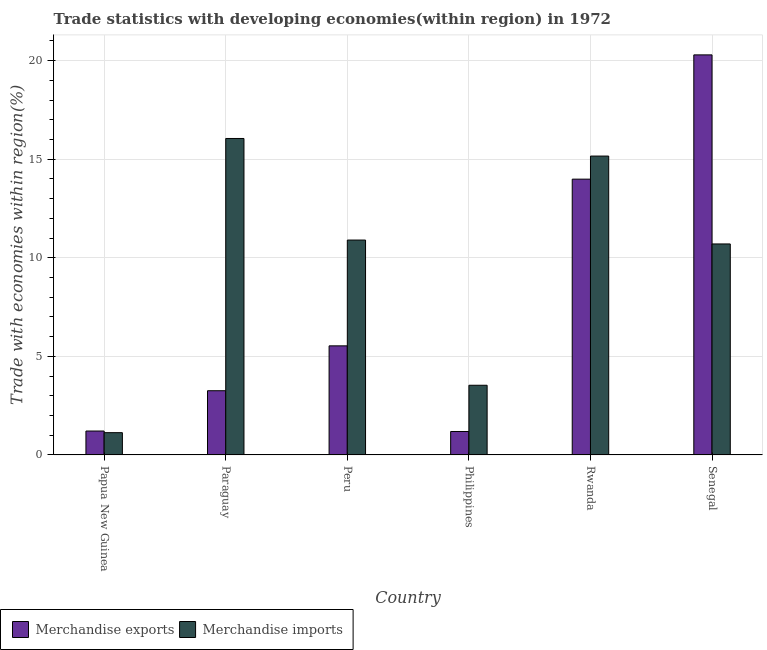How many groups of bars are there?
Provide a succinct answer. 6. Are the number of bars per tick equal to the number of legend labels?
Your answer should be very brief. Yes. Are the number of bars on each tick of the X-axis equal?
Provide a short and direct response. Yes. How many bars are there on the 2nd tick from the left?
Ensure brevity in your answer.  2. How many bars are there on the 5th tick from the right?
Ensure brevity in your answer.  2. What is the label of the 6th group of bars from the left?
Make the answer very short. Senegal. What is the merchandise exports in Philippines?
Your answer should be very brief. 1.19. Across all countries, what is the maximum merchandise imports?
Offer a very short reply. 16.05. Across all countries, what is the minimum merchandise exports?
Your answer should be very brief. 1.19. In which country was the merchandise exports maximum?
Give a very brief answer. Senegal. In which country was the merchandise imports minimum?
Offer a very short reply. Papua New Guinea. What is the total merchandise exports in the graph?
Keep it short and to the point. 45.48. What is the difference between the merchandise exports in Philippines and that in Rwanda?
Provide a short and direct response. -12.8. What is the difference between the merchandise imports in Paraguay and the merchandise exports in Rwanda?
Give a very brief answer. 2.06. What is the average merchandise exports per country?
Keep it short and to the point. 7.58. What is the difference between the merchandise imports and merchandise exports in Senegal?
Provide a succinct answer. -9.59. In how many countries, is the merchandise exports greater than 18 %?
Offer a very short reply. 1. What is the ratio of the merchandise exports in Paraguay to that in Senegal?
Provide a succinct answer. 0.16. What is the difference between the highest and the second highest merchandise imports?
Offer a terse response. 0.89. What is the difference between the highest and the lowest merchandise exports?
Keep it short and to the point. 19.1. What does the 2nd bar from the left in Peru represents?
Make the answer very short. Merchandise imports. How many bars are there?
Keep it short and to the point. 12. How many countries are there in the graph?
Your answer should be compact. 6. What is the difference between two consecutive major ticks on the Y-axis?
Your answer should be very brief. 5. Are the values on the major ticks of Y-axis written in scientific E-notation?
Keep it short and to the point. No. Does the graph contain grids?
Provide a short and direct response. Yes. Where does the legend appear in the graph?
Keep it short and to the point. Bottom left. What is the title of the graph?
Provide a succinct answer. Trade statistics with developing economies(within region) in 1972. Does "Long-term debt" appear as one of the legend labels in the graph?
Offer a terse response. No. What is the label or title of the Y-axis?
Offer a terse response. Trade with economies within region(%). What is the Trade with economies within region(%) of Merchandise exports in Papua New Guinea?
Your answer should be very brief. 1.21. What is the Trade with economies within region(%) in Merchandise imports in Papua New Guinea?
Your answer should be very brief. 1.13. What is the Trade with economies within region(%) in Merchandise exports in Paraguay?
Offer a very short reply. 3.26. What is the Trade with economies within region(%) of Merchandise imports in Paraguay?
Keep it short and to the point. 16.05. What is the Trade with economies within region(%) in Merchandise exports in Peru?
Offer a terse response. 5.53. What is the Trade with economies within region(%) of Merchandise imports in Peru?
Offer a terse response. 10.9. What is the Trade with economies within region(%) of Merchandise exports in Philippines?
Ensure brevity in your answer.  1.19. What is the Trade with economies within region(%) in Merchandise imports in Philippines?
Provide a succinct answer. 3.53. What is the Trade with economies within region(%) of Merchandise exports in Rwanda?
Make the answer very short. 13.99. What is the Trade with economies within region(%) of Merchandise imports in Rwanda?
Give a very brief answer. 15.16. What is the Trade with economies within region(%) in Merchandise exports in Senegal?
Make the answer very short. 20.29. What is the Trade with economies within region(%) of Merchandise imports in Senegal?
Give a very brief answer. 10.7. Across all countries, what is the maximum Trade with economies within region(%) in Merchandise exports?
Provide a succinct answer. 20.29. Across all countries, what is the maximum Trade with economies within region(%) in Merchandise imports?
Give a very brief answer. 16.05. Across all countries, what is the minimum Trade with economies within region(%) in Merchandise exports?
Make the answer very short. 1.19. Across all countries, what is the minimum Trade with economies within region(%) of Merchandise imports?
Your answer should be very brief. 1.13. What is the total Trade with economies within region(%) in Merchandise exports in the graph?
Provide a short and direct response. 45.48. What is the total Trade with economies within region(%) in Merchandise imports in the graph?
Your answer should be compact. 57.48. What is the difference between the Trade with economies within region(%) in Merchandise exports in Papua New Guinea and that in Paraguay?
Offer a very short reply. -2.04. What is the difference between the Trade with economies within region(%) of Merchandise imports in Papua New Guinea and that in Paraguay?
Your response must be concise. -14.92. What is the difference between the Trade with economies within region(%) in Merchandise exports in Papua New Guinea and that in Peru?
Your response must be concise. -4.32. What is the difference between the Trade with economies within region(%) in Merchandise imports in Papua New Guinea and that in Peru?
Your answer should be compact. -9.77. What is the difference between the Trade with economies within region(%) of Merchandise exports in Papua New Guinea and that in Philippines?
Offer a very short reply. 0.02. What is the difference between the Trade with economies within region(%) of Merchandise imports in Papua New Guinea and that in Philippines?
Your answer should be compact. -2.41. What is the difference between the Trade with economies within region(%) of Merchandise exports in Papua New Guinea and that in Rwanda?
Give a very brief answer. -12.78. What is the difference between the Trade with economies within region(%) in Merchandise imports in Papua New Guinea and that in Rwanda?
Provide a short and direct response. -14.03. What is the difference between the Trade with economies within region(%) in Merchandise exports in Papua New Guinea and that in Senegal?
Keep it short and to the point. -19.08. What is the difference between the Trade with economies within region(%) of Merchandise imports in Papua New Guinea and that in Senegal?
Provide a short and direct response. -9.57. What is the difference between the Trade with economies within region(%) of Merchandise exports in Paraguay and that in Peru?
Provide a short and direct response. -2.28. What is the difference between the Trade with economies within region(%) in Merchandise imports in Paraguay and that in Peru?
Provide a succinct answer. 5.15. What is the difference between the Trade with economies within region(%) of Merchandise exports in Paraguay and that in Philippines?
Your answer should be compact. 2.07. What is the difference between the Trade with economies within region(%) of Merchandise imports in Paraguay and that in Philippines?
Offer a very short reply. 12.52. What is the difference between the Trade with economies within region(%) of Merchandise exports in Paraguay and that in Rwanda?
Make the answer very short. -10.73. What is the difference between the Trade with economies within region(%) of Merchandise imports in Paraguay and that in Rwanda?
Provide a short and direct response. 0.89. What is the difference between the Trade with economies within region(%) of Merchandise exports in Paraguay and that in Senegal?
Ensure brevity in your answer.  -17.04. What is the difference between the Trade with economies within region(%) in Merchandise imports in Paraguay and that in Senegal?
Your answer should be very brief. 5.35. What is the difference between the Trade with economies within region(%) in Merchandise exports in Peru and that in Philippines?
Offer a terse response. 4.34. What is the difference between the Trade with economies within region(%) of Merchandise imports in Peru and that in Philippines?
Your answer should be very brief. 7.37. What is the difference between the Trade with economies within region(%) of Merchandise exports in Peru and that in Rwanda?
Ensure brevity in your answer.  -8.46. What is the difference between the Trade with economies within region(%) of Merchandise imports in Peru and that in Rwanda?
Your answer should be compact. -4.26. What is the difference between the Trade with economies within region(%) of Merchandise exports in Peru and that in Senegal?
Give a very brief answer. -14.76. What is the difference between the Trade with economies within region(%) in Merchandise imports in Peru and that in Senegal?
Provide a succinct answer. 0.2. What is the difference between the Trade with economies within region(%) of Merchandise exports in Philippines and that in Rwanda?
Give a very brief answer. -12.8. What is the difference between the Trade with economies within region(%) of Merchandise imports in Philippines and that in Rwanda?
Provide a short and direct response. -11.63. What is the difference between the Trade with economies within region(%) in Merchandise exports in Philippines and that in Senegal?
Provide a succinct answer. -19.1. What is the difference between the Trade with economies within region(%) in Merchandise imports in Philippines and that in Senegal?
Give a very brief answer. -7.17. What is the difference between the Trade with economies within region(%) of Merchandise exports in Rwanda and that in Senegal?
Ensure brevity in your answer.  -6.3. What is the difference between the Trade with economies within region(%) of Merchandise imports in Rwanda and that in Senegal?
Provide a short and direct response. 4.46. What is the difference between the Trade with economies within region(%) in Merchandise exports in Papua New Guinea and the Trade with economies within region(%) in Merchandise imports in Paraguay?
Provide a short and direct response. -14.84. What is the difference between the Trade with economies within region(%) in Merchandise exports in Papua New Guinea and the Trade with economies within region(%) in Merchandise imports in Peru?
Give a very brief answer. -9.69. What is the difference between the Trade with economies within region(%) of Merchandise exports in Papua New Guinea and the Trade with economies within region(%) of Merchandise imports in Philippines?
Make the answer very short. -2.32. What is the difference between the Trade with economies within region(%) of Merchandise exports in Papua New Guinea and the Trade with economies within region(%) of Merchandise imports in Rwanda?
Provide a short and direct response. -13.95. What is the difference between the Trade with economies within region(%) of Merchandise exports in Papua New Guinea and the Trade with economies within region(%) of Merchandise imports in Senegal?
Your answer should be very brief. -9.49. What is the difference between the Trade with economies within region(%) of Merchandise exports in Paraguay and the Trade with economies within region(%) of Merchandise imports in Peru?
Keep it short and to the point. -7.64. What is the difference between the Trade with economies within region(%) of Merchandise exports in Paraguay and the Trade with economies within region(%) of Merchandise imports in Philippines?
Your response must be concise. -0.28. What is the difference between the Trade with economies within region(%) in Merchandise exports in Paraguay and the Trade with economies within region(%) in Merchandise imports in Rwanda?
Ensure brevity in your answer.  -11.9. What is the difference between the Trade with economies within region(%) of Merchandise exports in Paraguay and the Trade with economies within region(%) of Merchandise imports in Senegal?
Ensure brevity in your answer.  -7.45. What is the difference between the Trade with economies within region(%) of Merchandise exports in Peru and the Trade with economies within region(%) of Merchandise imports in Philippines?
Offer a terse response. 2. What is the difference between the Trade with economies within region(%) of Merchandise exports in Peru and the Trade with economies within region(%) of Merchandise imports in Rwanda?
Offer a terse response. -9.63. What is the difference between the Trade with economies within region(%) of Merchandise exports in Peru and the Trade with economies within region(%) of Merchandise imports in Senegal?
Offer a very short reply. -5.17. What is the difference between the Trade with economies within region(%) of Merchandise exports in Philippines and the Trade with economies within region(%) of Merchandise imports in Rwanda?
Make the answer very short. -13.97. What is the difference between the Trade with economies within region(%) in Merchandise exports in Philippines and the Trade with economies within region(%) in Merchandise imports in Senegal?
Provide a succinct answer. -9.51. What is the difference between the Trade with economies within region(%) in Merchandise exports in Rwanda and the Trade with economies within region(%) in Merchandise imports in Senegal?
Offer a very short reply. 3.29. What is the average Trade with economies within region(%) of Merchandise exports per country?
Your answer should be very brief. 7.58. What is the average Trade with economies within region(%) in Merchandise imports per country?
Offer a terse response. 9.58. What is the difference between the Trade with economies within region(%) in Merchandise exports and Trade with economies within region(%) in Merchandise imports in Papua New Guinea?
Provide a succinct answer. 0.08. What is the difference between the Trade with economies within region(%) in Merchandise exports and Trade with economies within region(%) in Merchandise imports in Paraguay?
Keep it short and to the point. -12.8. What is the difference between the Trade with economies within region(%) of Merchandise exports and Trade with economies within region(%) of Merchandise imports in Peru?
Give a very brief answer. -5.37. What is the difference between the Trade with economies within region(%) in Merchandise exports and Trade with economies within region(%) in Merchandise imports in Philippines?
Your response must be concise. -2.35. What is the difference between the Trade with economies within region(%) in Merchandise exports and Trade with economies within region(%) in Merchandise imports in Rwanda?
Provide a short and direct response. -1.17. What is the difference between the Trade with economies within region(%) in Merchandise exports and Trade with economies within region(%) in Merchandise imports in Senegal?
Ensure brevity in your answer.  9.59. What is the ratio of the Trade with economies within region(%) in Merchandise exports in Papua New Guinea to that in Paraguay?
Your response must be concise. 0.37. What is the ratio of the Trade with economies within region(%) in Merchandise imports in Papua New Guinea to that in Paraguay?
Your response must be concise. 0.07. What is the ratio of the Trade with economies within region(%) in Merchandise exports in Papua New Guinea to that in Peru?
Offer a very short reply. 0.22. What is the ratio of the Trade with economies within region(%) of Merchandise imports in Papua New Guinea to that in Peru?
Your answer should be compact. 0.1. What is the ratio of the Trade with economies within region(%) in Merchandise imports in Papua New Guinea to that in Philippines?
Provide a short and direct response. 0.32. What is the ratio of the Trade with economies within region(%) in Merchandise exports in Papua New Guinea to that in Rwanda?
Ensure brevity in your answer.  0.09. What is the ratio of the Trade with economies within region(%) of Merchandise imports in Papua New Guinea to that in Rwanda?
Give a very brief answer. 0.07. What is the ratio of the Trade with economies within region(%) of Merchandise exports in Papua New Guinea to that in Senegal?
Offer a very short reply. 0.06. What is the ratio of the Trade with economies within region(%) in Merchandise imports in Papua New Guinea to that in Senegal?
Keep it short and to the point. 0.11. What is the ratio of the Trade with economies within region(%) in Merchandise exports in Paraguay to that in Peru?
Provide a succinct answer. 0.59. What is the ratio of the Trade with economies within region(%) in Merchandise imports in Paraguay to that in Peru?
Make the answer very short. 1.47. What is the ratio of the Trade with economies within region(%) of Merchandise exports in Paraguay to that in Philippines?
Your response must be concise. 2.74. What is the ratio of the Trade with economies within region(%) in Merchandise imports in Paraguay to that in Philippines?
Your response must be concise. 4.54. What is the ratio of the Trade with economies within region(%) in Merchandise exports in Paraguay to that in Rwanda?
Provide a short and direct response. 0.23. What is the ratio of the Trade with economies within region(%) of Merchandise imports in Paraguay to that in Rwanda?
Make the answer very short. 1.06. What is the ratio of the Trade with economies within region(%) in Merchandise exports in Paraguay to that in Senegal?
Offer a very short reply. 0.16. What is the ratio of the Trade with economies within region(%) in Merchandise imports in Paraguay to that in Senegal?
Keep it short and to the point. 1.5. What is the ratio of the Trade with economies within region(%) in Merchandise exports in Peru to that in Philippines?
Your answer should be compact. 4.65. What is the ratio of the Trade with economies within region(%) of Merchandise imports in Peru to that in Philippines?
Provide a short and direct response. 3.08. What is the ratio of the Trade with economies within region(%) in Merchandise exports in Peru to that in Rwanda?
Your response must be concise. 0.4. What is the ratio of the Trade with economies within region(%) in Merchandise imports in Peru to that in Rwanda?
Ensure brevity in your answer.  0.72. What is the ratio of the Trade with economies within region(%) in Merchandise exports in Peru to that in Senegal?
Offer a very short reply. 0.27. What is the ratio of the Trade with economies within region(%) of Merchandise imports in Peru to that in Senegal?
Offer a terse response. 1.02. What is the ratio of the Trade with economies within region(%) of Merchandise exports in Philippines to that in Rwanda?
Your answer should be compact. 0.09. What is the ratio of the Trade with economies within region(%) in Merchandise imports in Philippines to that in Rwanda?
Give a very brief answer. 0.23. What is the ratio of the Trade with economies within region(%) of Merchandise exports in Philippines to that in Senegal?
Make the answer very short. 0.06. What is the ratio of the Trade with economies within region(%) of Merchandise imports in Philippines to that in Senegal?
Provide a short and direct response. 0.33. What is the ratio of the Trade with economies within region(%) in Merchandise exports in Rwanda to that in Senegal?
Offer a terse response. 0.69. What is the ratio of the Trade with economies within region(%) of Merchandise imports in Rwanda to that in Senegal?
Your response must be concise. 1.42. What is the difference between the highest and the second highest Trade with economies within region(%) of Merchandise exports?
Provide a succinct answer. 6.3. What is the difference between the highest and the second highest Trade with economies within region(%) in Merchandise imports?
Provide a short and direct response. 0.89. What is the difference between the highest and the lowest Trade with economies within region(%) of Merchandise exports?
Give a very brief answer. 19.1. What is the difference between the highest and the lowest Trade with economies within region(%) in Merchandise imports?
Your response must be concise. 14.92. 